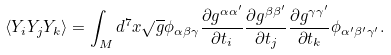Convert formula to latex. <formula><loc_0><loc_0><loc_500><loc_500>\langle Y _ { i } Y _ { j } Y _ { k } \rangle = \int _ { M } d ^ { 7 } x \sqrt { g } \phi _ { \alpha \beta \gamma } \frac { \partial g ^ { \alpha \alpha ^ { \prime } } } { \partial t _ { i } } \frac { \partial g ^ { \beta \beta ^ { \prime } } } { \partial t _ { j } } \frac { \partial g ^ { \gamma \gamma ^ { \prime } } } { \partial t _ { k } } \phi _ { \alpha ^ { \prime } \beta ^ { \prime } \gamma ^ { \prime } } .</formula> 